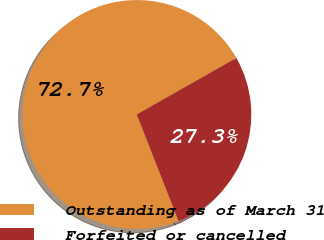<chart> <loc_0><loc_0><loc_500><loc_500><pie_chart><fcel>Outstanding as of March 31<fcel>Forfeited or cancelled<nl><fcel>72.74%<fcel>27.26%<nl></chart> 